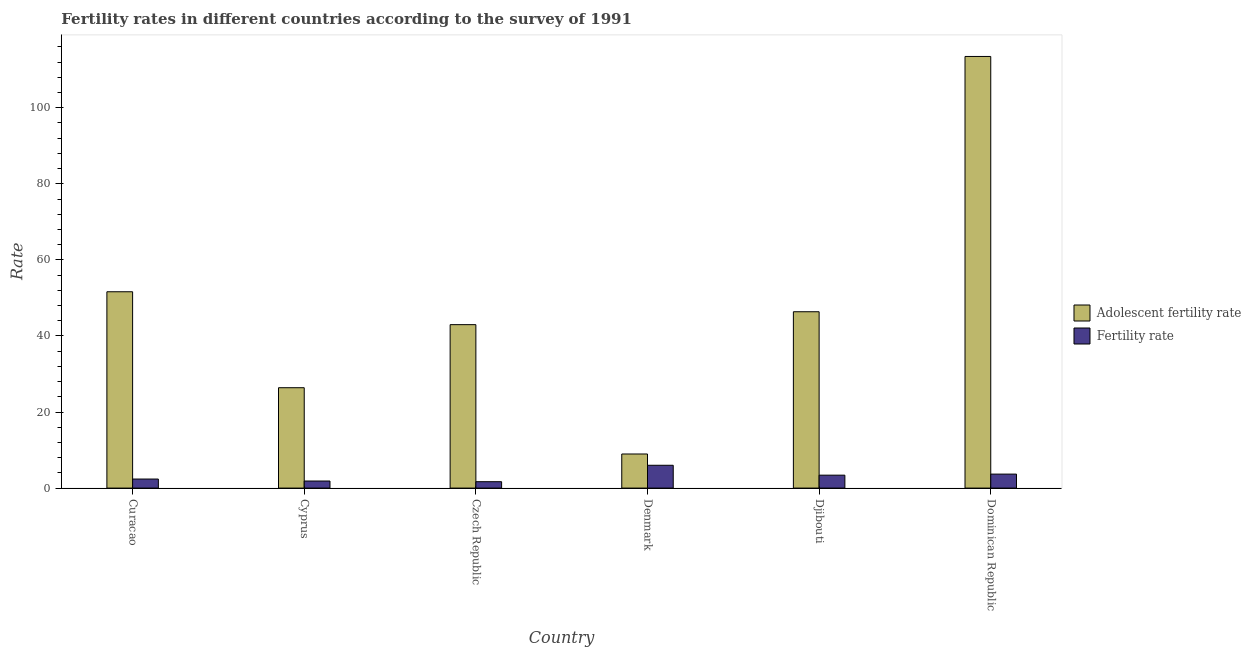How many different coloured bars are there?
Offer a terse response. 2. How many groups of bars are there?
Keep it short and to the point. 6. Are the number of bars per tick equal to the number of legend labels?
Your response must be concise. Yes. Are the number of bars on each tick of the X-axis equal?
Your answer should be very brief. Yes. How many bars are there on the 4th tick from the left?
Offer a very short reply. 2. What is the label of the 2nd group of bars from the left?
Provide a short and direct response. Cyprus. What is the fertility rate in Cyprus?
Offer a very short reply. 1.86. Across all countries, what is the maximum adolescent fertility rate?
Keep it short and to the point. 113.48. Across all countries, what is the minimum fertility rate?
Give a very brief answer. 1.68. In which country was the fertility rate maximum?
Keep it short and to the point. Denmark. In which country was the fertility rate minimum?
Your answer should be very brief. Czech Republic. What is the total fertility rate in the graph?
Your answer should be very brief. 19. What is the difference between the adolescent fertility rate in Czech Republic and that in Djibouti?
Offer a terse response. -3.39. What is the difference between the fertility rate in Djibouti and the adolescent fertility rate in Cyprus?
Your response must be concise. -22.99. What is the average adolescent fertility rate per country?
Your answer should be compact. 48.3. What is the difference between the fertility rate and adolescent fertility rate in Dominican Republic?
Ensure brevity in your answer.  -109.8. What is the ratio of the adolescent fertility rate in Czech Republic to that in Djibouti?
Make the answer very short. 0.93. What is the difference between the highest and the second highest adolescent fertility rate?
Provide a succinct answer. 61.86. What is the difference between the highest and the lowest fertility rate?
Your response must be concise. 4.32. Is the sum of the fertility rate in Djibouti and Dominican Republic greater than the maximum adolescent fertility rate across all countries?
Provide a short and direct response. No. What does the 1st bar from the left in Czech Republic represents?
Provide a short and direct response. Adolescent fertility rate. What does the 1st bar from the right in Djibouti represents?
Your answer should be very brief. Fertility rate. What is the difference between two consecutive major ticks on the Y-axis?
Provide a succinct answer. 20. Where does the legend appear in the graph?
Ensure brevity in your answer.  Center right. How many legend labels are there?
Your response must be concise. 2. What is the title of the graph?
Provide a succinct answer. Fertility rates in different countries according to the survey of 1991. Does "Chemicals" appear as one of the legend labels in the graph?
Make the answer very short. No. What is the label or title of the Y-axis?
Provide a succinct answer. Rate. What is the Rate in Adolescent fertility rate in Curacao?
Offer a very short reply. 51.62. What is the Rate in Fertility rate in Curacao?
Make the answer very short. 2.38. What is the Rate in Adolescent fertility rate in Cyprus?
Keep it short and to the point. 26.39. What is the Rate of Fertility rate in Cyprus?
Offer a terse response. 1.86. What is the Rate in Adolescent fertility rate in Czech Republic?
Make the answer very short. 42.97. What is the Rate of Fertility rate in Czech Republic?
Offer a terse response. 1.68. What is the Rate of Adolescent fertility rate in Denmark?
Your answer should be very brief. 8.96. What is the Rate of Fertility rate in Denmark?
Provide a short and direct response. 6. What is the Rate in Adolescent fertility rate in Djibouti?
Your answer should be compact. 46.36. What is the Rate of Fertility rate in Djibouti?
Your response must be concise. 3.4. What is the Rate of Adolescent fertility rate in Dominican Republic?
Provide a short and direct response. 113.48. What is the Rate of Fertility rate in Dominican Republic?
Your answer should be compact. 3.68. Across all countries, what is the maximum Rate of Adolescent fertility rate?
Offer a terse response. 113.48. Across all countries, what is the maximum Rate of Fertility rate?
Your answer should be compact. 6. Across all countries, what is the minimum Rate of Adolescent fertility rate?
Give a very brief answer. 8.96. Across all countries, what is the minimum Rate in Fertility rate?
Make the answer very short. 1.68. What is the total Rate in Adolescent fertility rate in the graph?
Your answer should be compact. 289.79. What is the total Rate in Fertility rate in the graph?
Your answer should be compact. 19. What is the difference between the Rate in Adolescent fertility rate in Curacao and that in Cyprus?
Give a very brief answer. 25.23. What is the difference between the Rate in Fertility rate in Curacao and that in Cyprus?
Provide a short and direct response. 0.52. What is the difference between the Rate in Adolescent fertility rate in Curacao and that in Czech Republic?
Ensure brevity in your answer.  8.65. What is the difference between the Rate of Fertility rate in Curacao and that in Czech Republic?
Provide a succinct answer. 0.7. What is the difference between the Rate of Adolescent fertility rate in Curacao and that in Denmark?
Offer a very short reply. 42.65. What is the difference between the Rate in Fertility rate in Curacao and that in Denmark?
Offer a very short reply. -3.62. What is the difference between the Rate of Adolescent fertility rate in Curacao and that in Djibouti?
Offer a terse response. 5.25. What is the difference between the Rate of Fertility rate in Curacao and that in Djibouti?
Offer a terse response. -1.02. What is the difference between the Rate in Adolescent fertility rate in Curacao and that in Dominican Republic?
Make the answer very short. -61.86. What is the difference between the Rate in Fertility rate in Curacao and that in Dominican Republic?
Keep it short and to the point. -1.3. What is the difference between the Rate of Adolescent fertility rate in Cyprus and that in Czech Republic?
Give a very brief answer. -16.58. What is the difference between the Rate of Fertility rate in Cyprus and that in Czech Republic?
Give a very brief answer. 0.18. What is the difference between the Rate in Adolescent fertility rate in Cyprus and that in Denmark?
Your answer should be very brief. 17.43. What is the difference between the Rate in Fertility rate in Cyprus and that in Denmark?
Provide a succinct answer. -4.14. What is the difference between the Rate of Adolescent fertility rate in Cyprus and that in Djibouti?
Offer a very short reply. -19.97. What is the difference between the Rate in Fertility rate in Cyprus and that in Djibouti?
Offer a very short reply. -1.54. What is the difference between the Rate in Adolescent fertility rate in Cyprus and that in Dominican Republic?
Your response must be concise. -87.09. What is the difference between the Rate of Fertility rate in Cyprus and that in Dominican Republic?
Offer a terse response. -1.82. What is the difference between the Rate of Adolescent fertility rate in Czech Republic and that in Denmark?
Give a very brief answer. 34.01. What is the difference between the Rate of Fertility rate in Czech Republic and that in Denmark?
Make the answer very short. -4.32. What is the difference between the Rate of Adolescent fertility rate in Czech Republic and that in Djibouti?
Make the answer very short. -3.39. What is the difference between the Rate of Fertility rate in Czech Republic and that in Djibouti?
Give a very brief answer. -1.72. What is the difference between the Rate in Adolescent fertility rate in Czech Republic and that in Dominican Republic?
Offer a very short reply. -70.51. What is the difference between the Rate in Fertility rate in Czech Republic and that in Dominican Republic?
Make the answer very short. -2. What is the difference between the Rate of Adolescent fertility rate in Denmark and that in Djibouti?
Provide a succinct answer. -37.4. What is the difference between the Rate of Fertility rate in Denmark and that in Djibouti?
Ensure brevity in your answer.  2.6. What is the difference between the Rate in Adolescent fertility rate in Denmark and that in Dominican Republic?
Your response must be concise. -104.51. What is the difference between the Rate of Fertility rate in Denmark and that in Dominican Republic?
Give a very brief answer. 2.32. What is the difference between the Rate in Adolescent fertility rate in Djibouti and that in Dominican Republic?
Give a very brief answer. -67.11. What is the difference between the Rate of Fertility rate in Djibouti and that in Dominican Republic?
Offer a terse response. -0.28. What is the difference between the Rate of Adolescent fertility rate in Curacao and the Rate of Fertility rate in Cyprus?
Offer a very short reply. 49.76. What is the difference between the Rate of Adolescent fertility rate in Curacao and the Rate of Fertility rate in Czech Republic?
Your answer should be compact. 49.94. What is the difference between the Rate in Adolescent fertility rate in Curacao and the Rate in Fertility rate in Denmark?
Offer a terse response. 45.62. What is the difference between the Rate of Adolescent fertility rate in Curacao and the Rate of Fertility rate in Djibouti?
Your answer should be very brief. 48.22. What is the difference between the Rate in Adolescent fertility rate in Curacao and the Rate in Fertility rate in Dominican Republic?
Make the answer very short. 47.94. What is the difference between the Rate of Adolescent fertility rate in Cyprus and the Rate of Fertility rate in Czech Republic?
Make the answer very short. 24.71. What is the difference between the Rate in Adolescent fertility rate in Cyprus and the Rate in Fertility rate in Denmark?
Your answer should be very brief. 20.39. What is the difference between the Rate in Adolescent fertility rate in Cyprus and the Rate in Fertility rate in Djibouti?
Your response must be concise. 22.99. What is the difference between the Rate in Adolescent fertility rate in Cyprus and the Rate in Fertility rate in Dominican Republic?
Your answer should be compact. 22.71. What is the difference between the Rate in Adolescent fertility rate in Czech Republic and the Rate in Fertility rate in Denmark?
Your answer should be compact. 36.97. What is the difference between the Rate in Adolescent fertility rate in Czech Republic and the Rate in Fertility rate in Djibouti?
Offer a terse response. 39.57. What is the difference between the Rate in Adolescent fertility rate in Czech Republic and the Rate in Fertility rate in Dominican Republic?
Your answer should be very brief. 39.29. What is the difference between the Rate in Adolescent fertility rate in Denmark and the Rate in Fertility rate in Djibouti?
Give a very brief answer. 5.57. What is the difference between the Rate in Adolescent fertility rate in Denmark and the Rate in Fertility rate in Dominican Republic?
Offer a terse response. 5.29. What is the difference between the Rate of Adolescent fertility rate in Djibouti and the Rate of Fertility rate in Dominican Republic?
Your answer should be compact. 42.68. What is the average Rate in Adolescent fertility rate per country?
Keep it short and to the point. 48.3. What is the average Rate of Fertility rate per country?
Your response must be concise. 3.17. What is the difference between the Rate in Adolescent fertility rate and Rate in Fertility rate in Curacao?
Make the answer very short. 49.24. What is the difference between the Rate of Adolescent fertility rate and Rate of Fertility rate in Cyprus?
Provide a short and direct response. 24.53. What is the difference between the Rate in Adolescent fertility rate and Rate in Fertility rate in Czech Republic?
Offer a very short reply. 41.29. What is the difference between the Rate in Adolescent fertility rate and Rate in Fertility rate in Denmark?
Make the answer very short. 2.96. What is the difference between the Rate in Adolescent fertility rate and Rate in Fertility rate in Djibouti?
Your response must be concise. 42.97. What is the difference between the Rate in Adolescent fertility rate and Rate in Fertility rate in Dominican Republic?
Offer a terse response. 109.8. What is the ratio of the Rate of Adolescent fertility rate in Curacao to that in Cyprus?
Your response must be concise. 1.96. What is the ratio of the Rate of Fertility rate in Curacao to that in Cyprus?
Provide a short and direct response. 1.28. What is the ratio of the Rate in Adolescent fertility rate in Curacao to that in Czech Republic?
Give a very brief answer. 1.2. What is the ratio of the Rate in Fertility rate in Curacao to that in Czech Republic?
Provide a succinct answer. 1.42. What is the ratio of the Rate of Adolescent fertility rate in Curacao to that in Denmark?
Give a very brief answer. 5.76. What is the ratio of the Rate of Fertility rate in Curacao to that in Denmark?
Provide a short and direct response. 0.4. What is the ratio of the Rate of Adolescent fertility rate in Curacao to that in Djibouti?
Keep it short and to the point. 1.11. What is the ratio of the Rate of Fertility rate in Curacao to that in Djibouti?
Provide a short and direct response. 0.7. What is the ratio of the Rate of Adolescent fertility rate in Curacao to that in Dominican Republic?
Keep it short and to the point. 0.45. What is the ratio of the Rate of Fertility rate in Curacao to that in Dominican Republic?
Keep it short and to the point. 0.65. What is the ratio of the Rate of Adolescent fertility rate in Cyprus to that in Czech Republic?
Provide a short and direct response. 0.61. What is the ratio of the Rate of Fertility rate in Cyprus to that in Czech Republic?
Offer a terse response. 1.11. What is the ratio of the Rate of Adolescent fertility rate in Cyprus to that in Denmark?
Provide a short and direct response. 2.94. What is the ratio of the Rate of Fertility rate in Cyprus to that in Denmark?
Ensure brevity in your answer.  0.31. What is the ratio of the Rate in Adolescent fertility rate in Cyprus to that in Djibouti?
Provide a short and direct response. 0.57. What is the ratio of the Rate of Fertility rate in Cyprus to that in Djibouti?
Keep it short and to the point. 0.55. What is the ratio of the Rate of Adolescent fertility rate in Cyprus to that in Dominican Republic?
Offer a very short reply. 0.23. What is the ratio of the Rate of Fertility rate in Cyprus to that in Dominican Republic?
Offer a very short reply. 0.51. What is the ratio of the Rate in Adolescent fertility rate in Czech Republic to that in Denmark?
Provide a succinct answer. 4.79. What is the ratio of the Rate of Fertility rate in Czech Republic to that in Denmark?
Offer a terse response. 0.28. What is the ratio of the Rate of Adolescent fertility rate in Czech Republic to that in Djibouti?
Give a very brief answer. 0.93. What is the ratio of the Rate in Fertility rate in Czech Republic to that in Djibouti?
Make the answer very short. 0.49. What is the ratio of the Rate in Adolescent fertility rate in Czech Republic to that in Dominican Republic?
Ensure brevity in your answer.  0.38. What is the ratio of the Rate of Fertility rate in Czech Republic to that in Dominican Republic?
Keep it short and to the point. 0.46. What is the ratio of the Rate in Adolescent fertility rate in Denmark to that in Djibouti?
Give a very brief answer. 0.19. What is the ratio of the Rate in Fertility rate in Denmark to that in Djibouti?
Provide a short and direct response. 1.77. What is the ratio of the Rate in Adolescent fertility rate in Denmark to that in Dominican Republic?
Ensure brevity in your answer.  0.08. What is the ratio of the Rate in Fertility rate in Denmark to that in Dominican Republic?
Your answer should be very brief. 1.63. What is the ratio of the Rate of Adolescent fertility rate in Djibouti to that in Dominican Republic?
Give a very brief answer. 0.41. What is the ratio of the Rate of Fertility rate in Djibouti to that in Dominican Republic?
Provide a succinct answer. 0.92. What is the difference between the highest and the second highest Rate in Adolescent fertility rate?
Offer a very short reply. 61.86. What is the difference between the highest and the second highest Rate in Fertility rate?
Offer a terse response. 2.32. What is the difference between the highest and the lowest Rate in Adolescent fertility rate?
Your answer should be compact. 104.51. What is the difference between the highest and the lowest Rate in Fertility rate?
Your response must be concise. 4.32. 